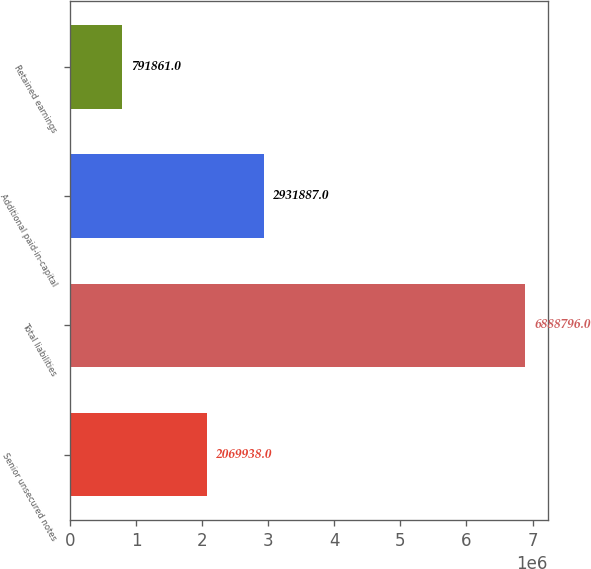Convert chart. <chart><loc_0><loc_0><loc_500><loc_500><bar_chart><fcel>Senior unsecured notes<fcel>Total liabilities<fcel>Additional paid-in-capital<fcel>Retained earnings<nl><fcel>2.06994e+06<fcel>6.8888e+06<fcel>2.93189e+06<fcel>791861<nl></chart> 